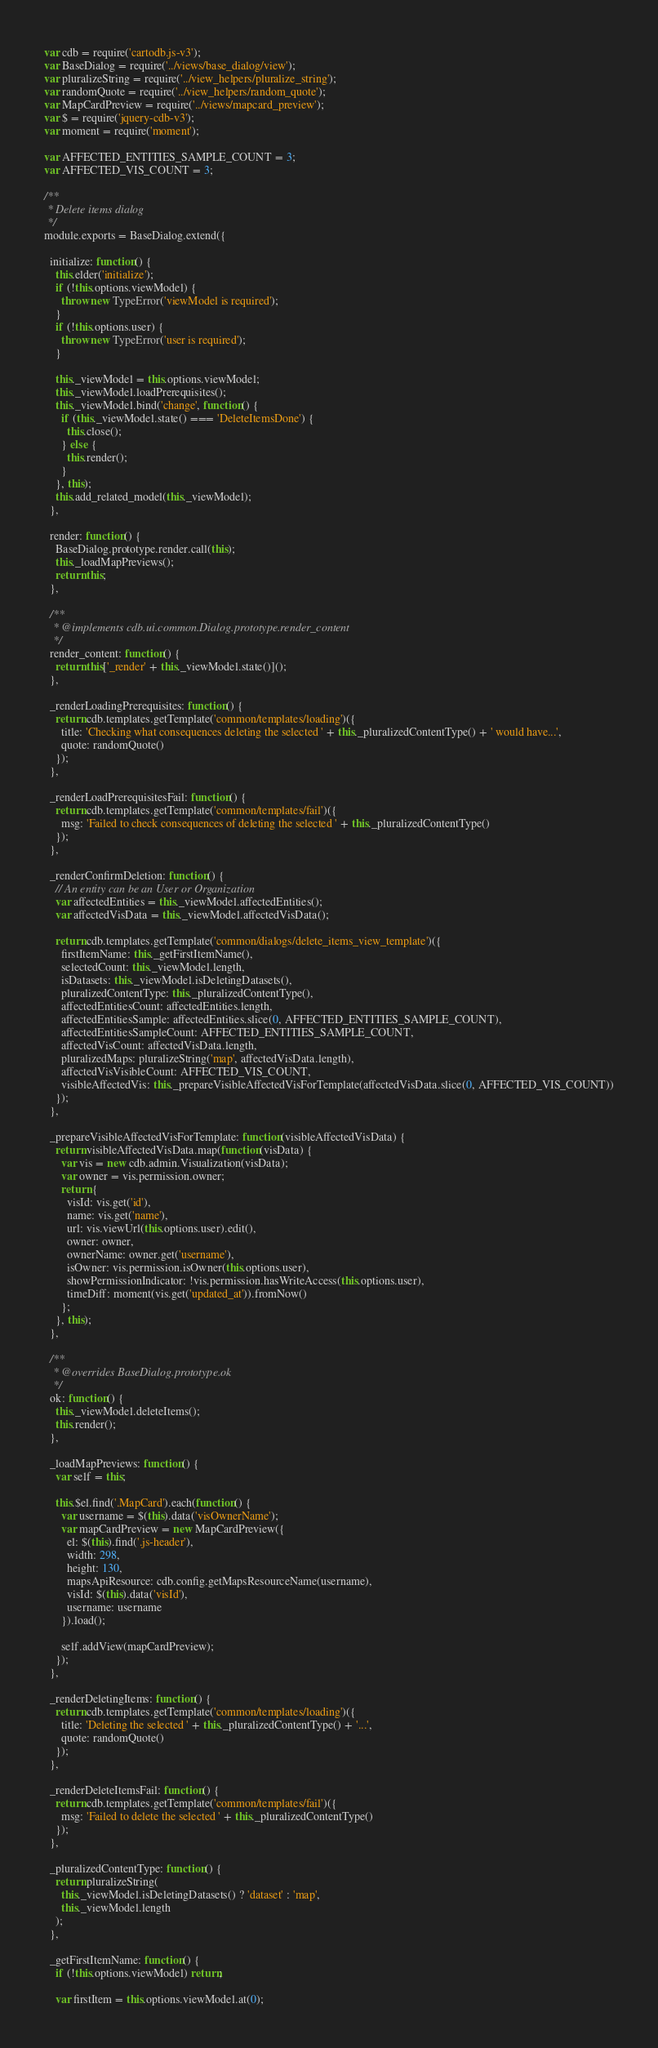<code> <loc_0><loc_0><loc_500><loc_500><_JavaScript_>var cdb = require('cartodb.js-v3');
var BaseDialog = require('../views/base_dialog/view');
var pluralizeString = require('../view_helpers/pluralize_string');
var randomQuote = require('../view_helpers/random_quote');
var MapCardPreview = require('../views/mapcard_preview');
var $ = require('jquery-cdb-v3');
var moment = require('moment');

var AFFECTED_ENTITIES_SAMPLE_COUNT = 3;
var AFFECTED_VIS_COUNT = 3;

/**
 * Delete items dialog
 */
module.exports = BaseDialog.extend({

  initialize: function() {
    this.elder('initialize');
    if (!this.options.viewModel) {
      throw new TypeError('viewModel is required');
    }
    if (!this.options.user) {
      throw new TypeError('user is required');
    }

    this._viewModel = this.options.viewModel;
    this._viewModel.loadPrerequisites();
    this._viewModel.bind('change', function() {
      if (this._viewModel.state() === 'DeleteItemsDone') {
        this.close();
      } else {
        this.render();
      }
    }, this);
    this.add_related_model(this._viewModel);
  },

  render: function() {
    BaseDialog.prototype.render.call(this);
    this._loadMapPreviews();
    return this;
  },

  /**
   * @implements cdb.ui.common.Dialog.prototype.render_content
   */
  render_content: function() {
    return this['_render' + this._viewModel.state()]();
  },

  _renderLoadingPrerequisites: function() {
    return cdb.templates.getTemplate('common/templates/loading')({
      title: 'Checking what consequences deleting the selected ' + this._pluralizedContentType() + ' would have...',
      quote: randomQuote()
    });
  },

  _renderLoadPrerequisitesFail: function() {
    return cdb.templates.getTemplate('common/templates/fail')({
      msg: 'Failed to check consequences of deleting the selected ' + this._pluralizedContentType()
    });
  },

  _renderConfirmDeletion: function() {
    // An entity can be an User or Organization
    var affectedEntities = this._viewModel.affectedEntities();
    var affectedVisData = this._viewModel.affectedVisData();

    return cdb.templates.getTemplate('common/dialogs/delete_items_view_template')({
      firstItemName: this._getFirstItemName(),
      selectedCount: this._viewModel.length,
      isDatasets: this._viewModel.isDeletingDatasets(),
      pluralizedContentType: this._pluralizedContentType(),
      affectedEntitiesCount: affectedEntities.length,
      affectedEntitiesSample: affectedEntities.slice(0, AFFECTED_ENTITIES_SAMPLE_COUNT),
      affectedEntitiesSampleCount: AFFECTED_ENTITIES_SAMPLE_COUNT,
      affectedVisCount: affectedVisData.length,
      pluralizedMaps: pluralizeString('map', affectedVisData.length),
      affectedVisVisibleCount: AFFECTED_VIS_COUNT,
      visibleAffectedVis: this._prepareVisibleAffectedVisForTemplate(affectedVisData.slice(0, AFFECTED_VIS_COUNT))
    });
  },

  _prepareVisibleAffectedVisForTemplate: function(visibleAffectedVisData) {
    return visibleAffectedVisData.map(function(visData) {
      var vis = new cdb.admin.Visualization(visData);
      var owner = vis.permission.owner;
      return {
        visId: vis.get('id'),
        name: vis.get('name'),
        url: vis.viewUrl(this.options.user).edit(),
        owner: owner,
        ownerName: owner.get('username'),
        isOwner: vis.permission.isOwner(this.options.user),
        showPermissionIndicator: !vis.permission.hasWriteAccess(this.options.user),
        timeDiff: moment(vis.get('updated_at')).fromNow()
      };
    }, this);
  },

  /**
   * @overrides BaseDialog.prototype.ok
   */
  ok: function() {
    this._viewModel.deleteItems();
    this.render();
  },

  _loadMapPreviews: function() {
    var self = this;

    this.$el.find('.MapCard').each(function() {
      var username = $(this).data('visOwnerName');
      var mapCardPreview = new MapCardPreview({
        el: $(this).find('.js-header'),
        width: 298,
        height: 130,
        mapsApiResource: cdb.config.getMapsResourceName(username),
        visId: $(this).data('visId'),
        username: username
      }).load();

      self.addView(mapCardPreview);
    });
  },

  _renderDeletingItems: function() {
    return cdb.templates.getTemplate('common/templates/loading')({
      title: 'Deleting the selected ' + this._pluralizedContentType() + '...',
      quote: randomQuote()
    });
  },

  _renderDeleteItemsFail: function() {
    return cdb.templates.getTemplate('common/templates/fail')({
      msg: 'Failed to delete the selected ' + this._pluralizedContentType()
    });
  },

  _pluralizedContentType: function() {
    return pluralizeString(
      this._viewModel.isDeletingDatasets() ? 'dataset' : 'map',
      this._viewModel.length
    );
  },

  _getFirstItemName: function() {
    if (!this.options.viewModel) return;

    var firstItem = this.options.viewModel.at(0);
</code> 